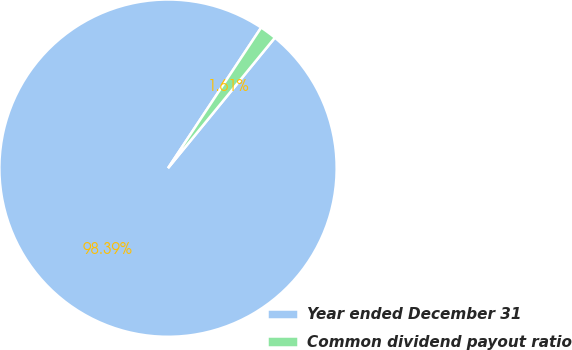<chart> <loc_0><loc_0><loc_500><loc_500><pie_chart><fcel>Year ended December 31<fcel>Common dividend payout ratio<nl><fcel>98.39%<fcel>1.61%<nl></chart> 